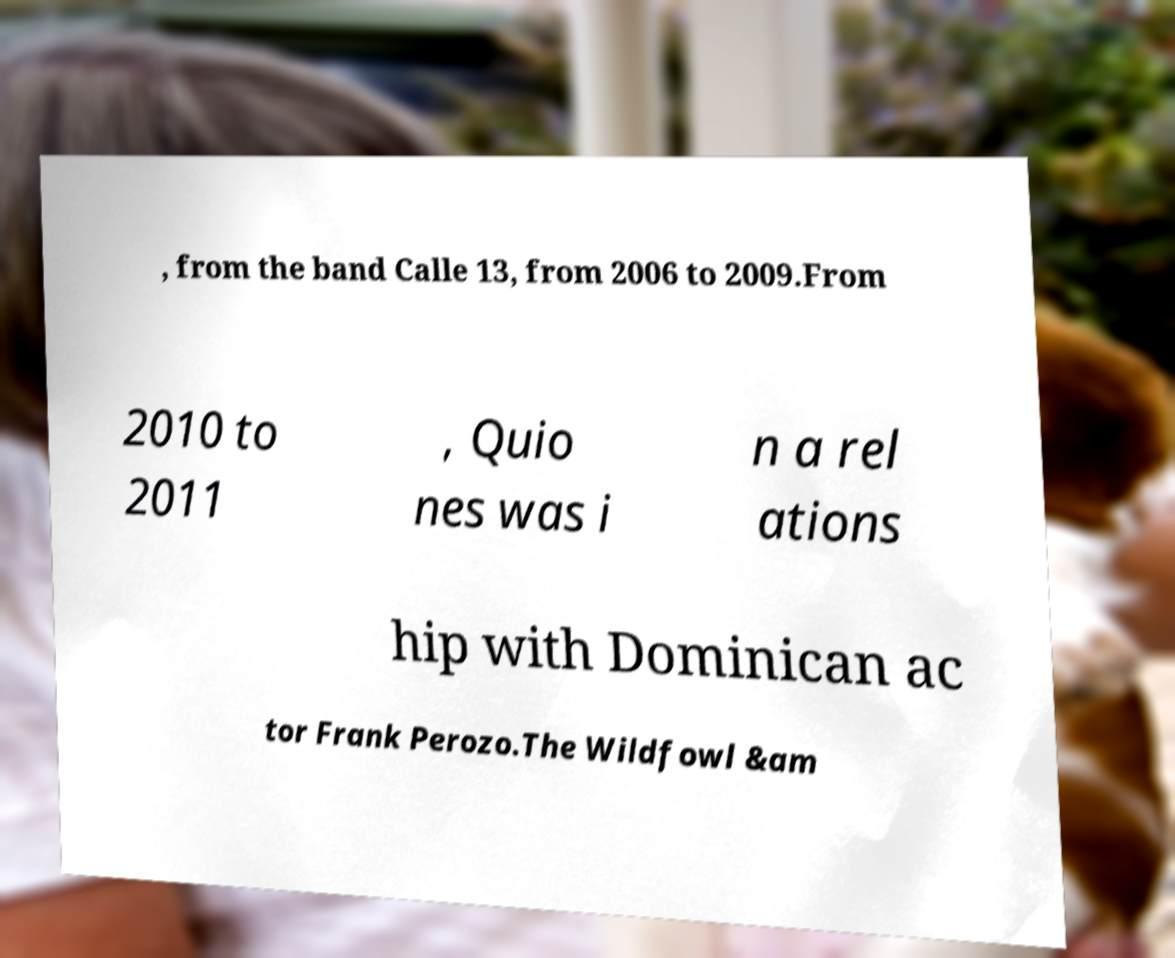What messages or text are displayed in this image? I need them in a readable, typed format. , from the band Calle 13, from 2006 to 2009.From 2010 to 2011 , Quio nes was i n a rel ations hip with Dominican ac tor Frank Perozo.The Wildfowl &am 